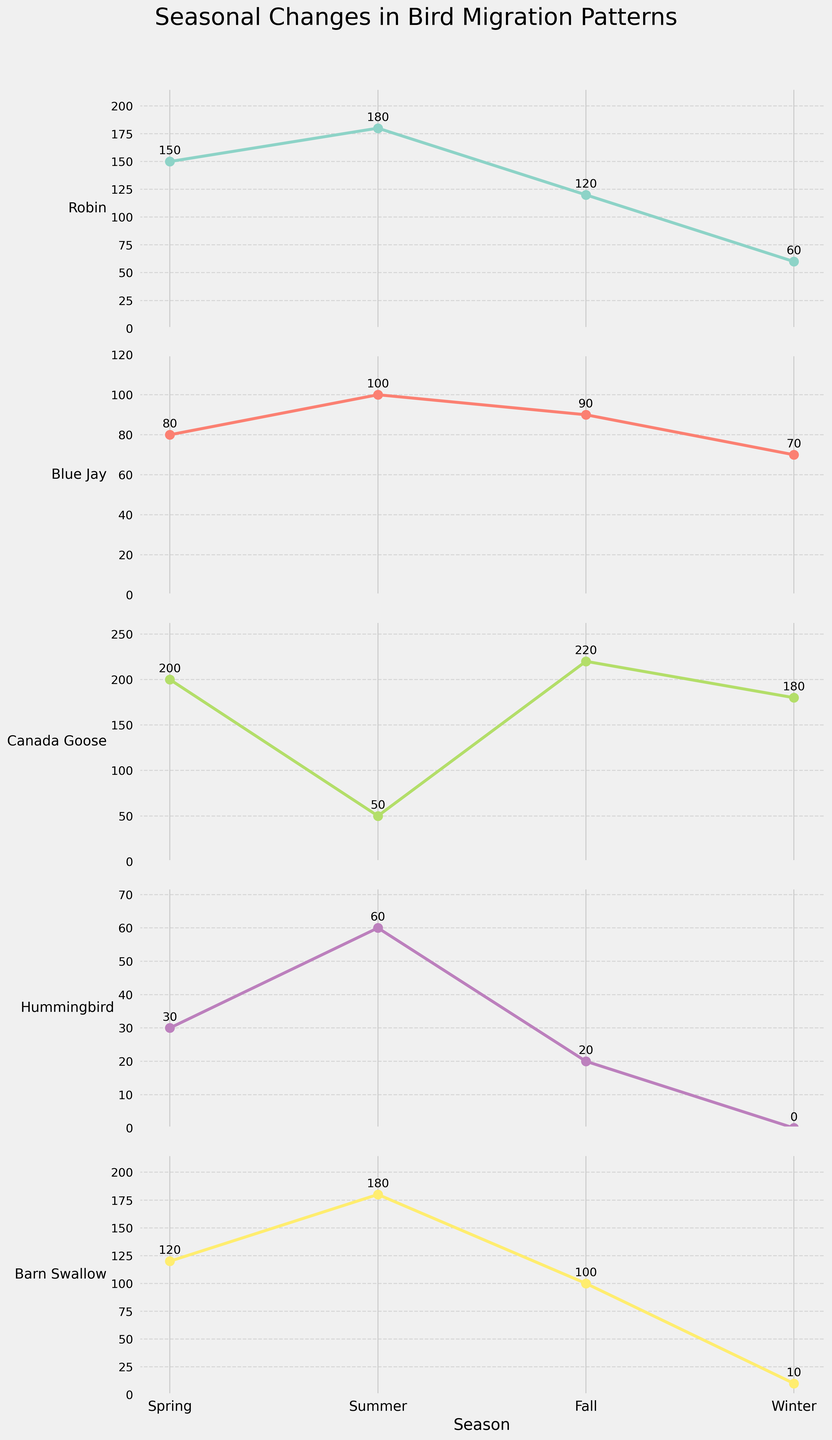What's the total number of Robins spotted over all seasons? Sum up the number of Robins spotted in Spring, Summer, Fall, and Winter: 150 + 180 + 120 + 60 = 510
Answer: 510 Which bird species has the highest count in Winter? Refer to the subplot for Winter and compare all bird species counts. The highest count is 180 for Canada Goose.
Answer: Canada Goose What is the average number of Blue Jays spotted across all seasons? Sum up the counts for Blue Jays across all seasons and divide by the number of seasons: (80 + 100 + 90 + 70) / 4 = 85
Answer: 85 Is the number of Barn Swallows higher in Spring or Fall? Compare the counts for Barn Swallows in Spring (120) and Fall (100). 120 > 100, so Spring has a higher count.
Answer: Spring Which season shows the least number of Hummingbirds? Look at the Hummingbird subplot and identify the season with the lowest count, which is Winter at 0.
Answer: Winter How much does the count of Canada Geese change from Spring to Fall? Subtract the count of Canada Geese in Spring from the count in Fall: 220 - 200 = 20
Answer: 20 Are there more Blue Jays or Robins in Summer? Compare the counts for Blue Jays (100) and Robins (180) in Summer. There are more Robins.
Answer: Robins What is the difference between the highest and lowest number of Hummingbirds spotted in any season? The highest number of Hummingbirds is 60 (Summer), and the lowest is 0 (Winter). The difference is 60 - 0 = 60.
Answer: 60 In which season do we see the maximum Barn Swallow sightings? Check the Barn Swallow subplot for the highest value. The maximum count is 180 in Summer.
Answer: Summer Which bird species shows the greatest variation in count across different seasons? Calculate the range (difference between the maximum and minimum counts) for each species and compare. Robins have the greatest range: 180 (Summer) - 60 (Winter) = 120.
Answer: Robins 